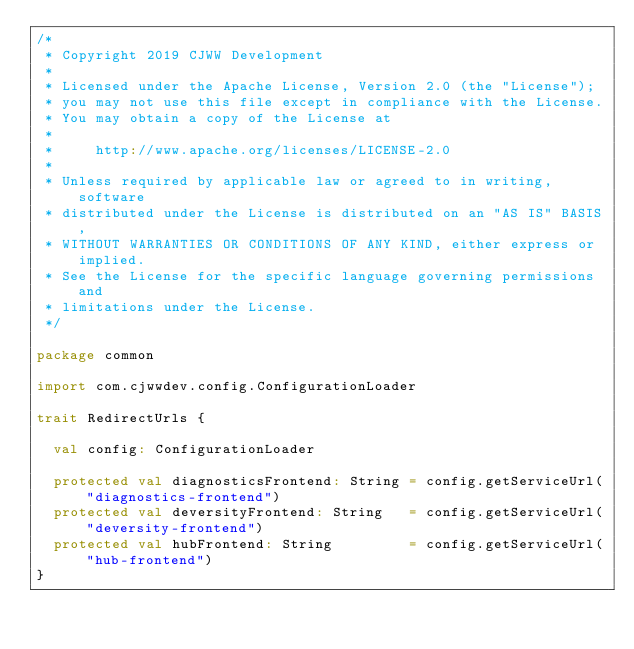Convert code to text. <code><loc_0><loc_0><loc_500><loc_500><_Scala_>/*
 * Copyright 2019 CJWW Development
 *
 * Licensed under the Apache License, Version 2.0 (the "License");
 * you may not use this file except in compliance with the License.
 * You may obtain a copy of the License at
 *
 *     http://www.apache.org/licenses/LICENSE-2.0
 *
 * Unless required by applicable law or agreed to in writing, software
 * distributed under the License is distributed on an "AS IS" BASIS,
 * WITHOUT WARRANTIES OR CONDITIONS OF ANY KIND, either express or implied.
 * See the License for the specific language governing permissions and
 * limitations under the License.
 */

package common

import com.cjwwdev.config.ConfigurationLoader

trait RedirectUrls {

  val config: ConfigurationLoader

  protected val diagnosticsFrontend: String = config.getServiceUrl("diagnostics-frontend")
  protected val deversityFrontend: String   = config.getServiceUrl("deversity-frontend")
  protected val hubFrontend: String         = config.getServiceUrl("hub-frontend")
}
</code> 